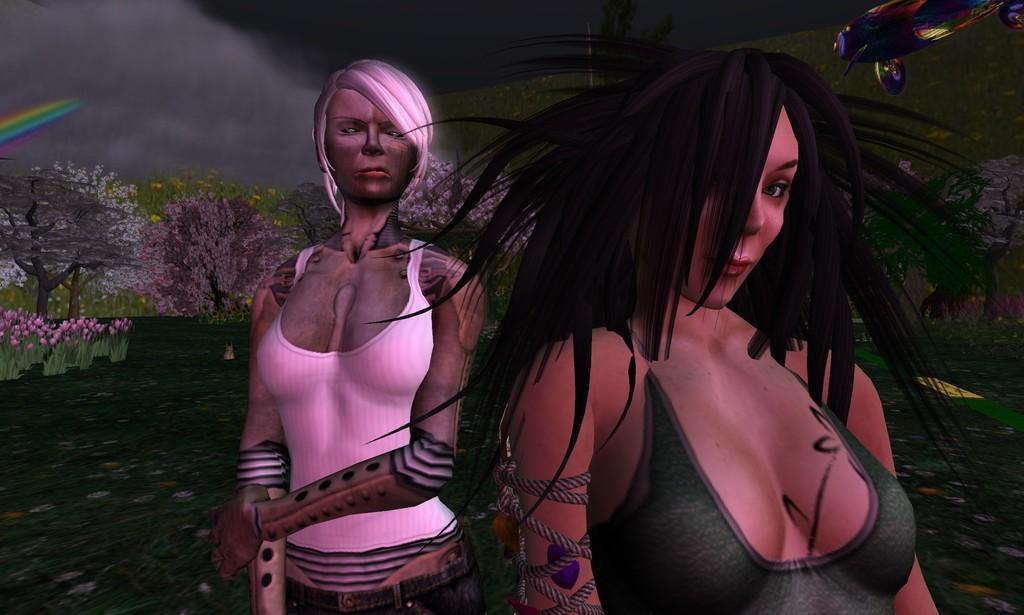Could you give a brief overview of what you see in this image? This is an animation, in this image in the foreground there are two women. And in the background there are some plants, trees, flowers, grass. And in the top right hand corner there is some object, at the bottom there is grass. 